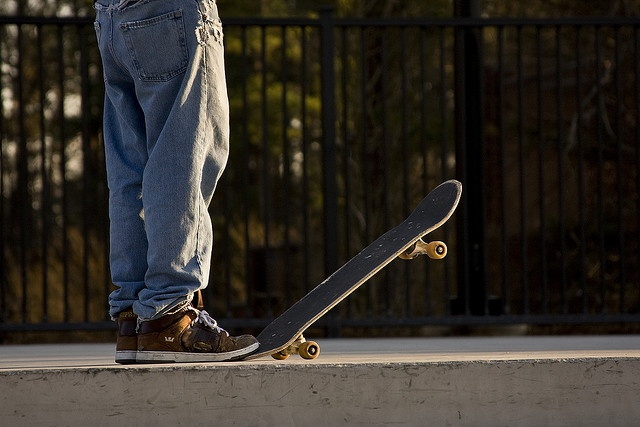Describe the objects in this image and their specific colors. I can see people in gray, black, navy, and darkblue tones and skateboard in gray, black, and tan tones in this image. 